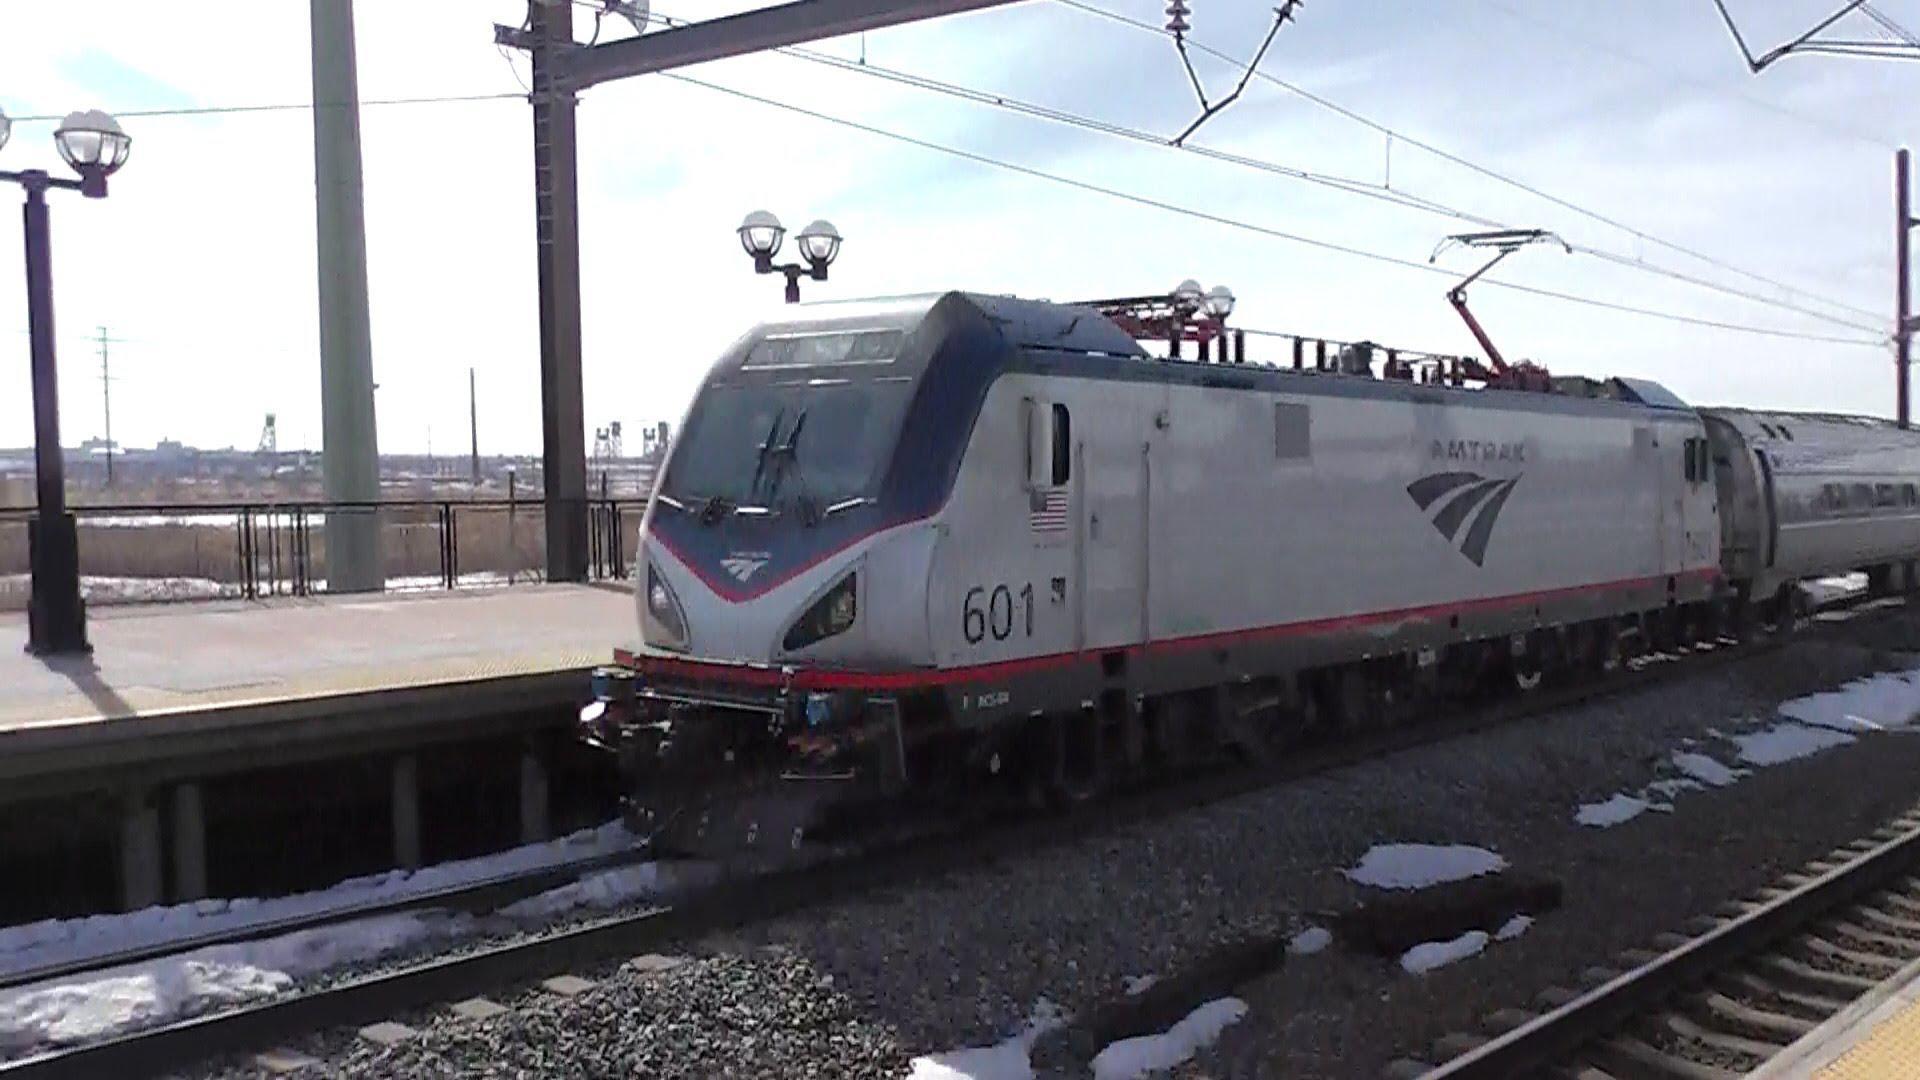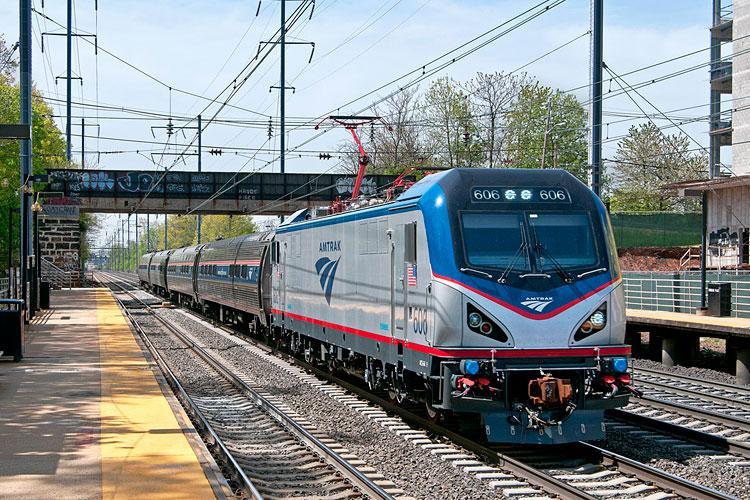The first image is the image on the left, the second image is the image on the right. For the images shown, is this caption "Each train is headed in the same direction." true? Answer yes or no. No. 